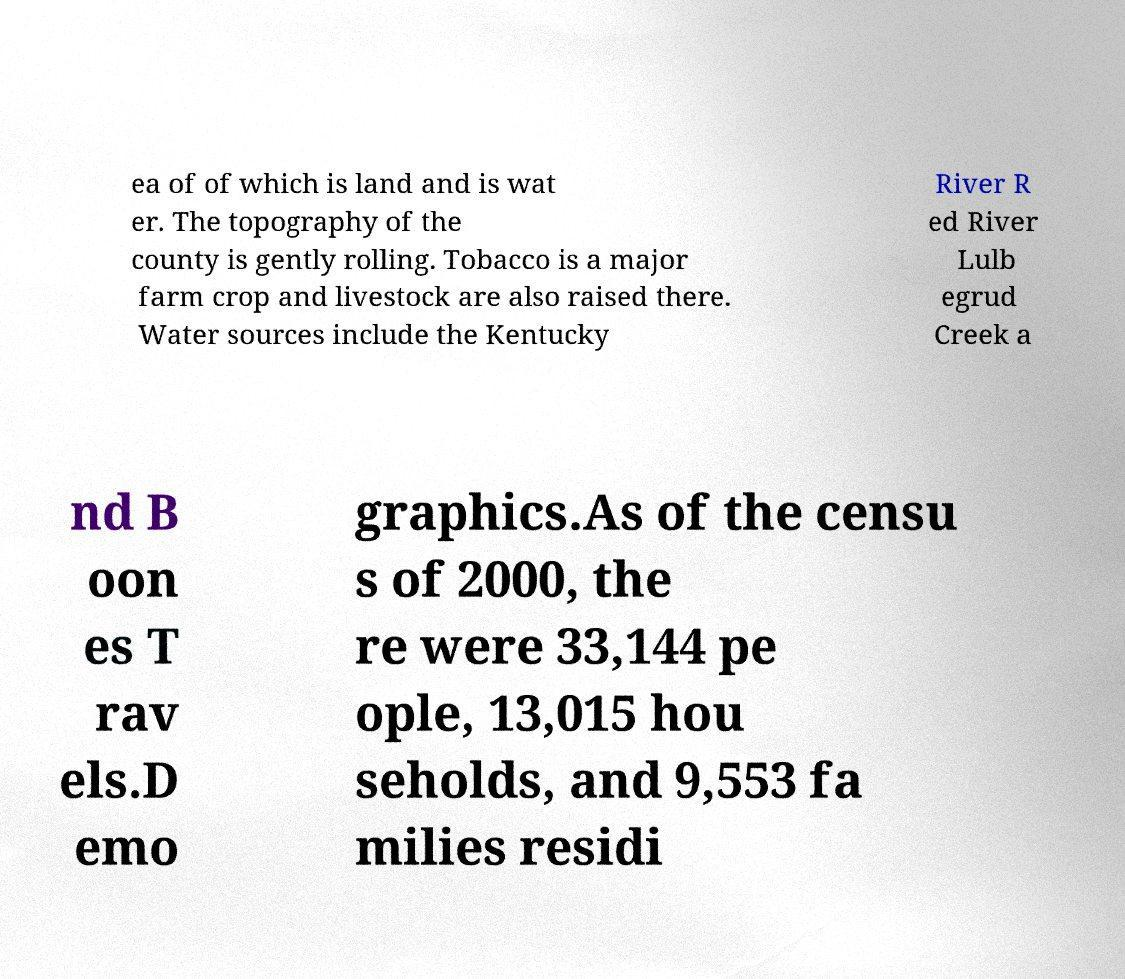For documentation purposes, I need the text within this image transcribed. Could you provide that? ea of of which is land and is wat er. The topography of the county is gently rolling. Tobacco is a major farm crop and livestock are also raised there. Water sources include the Kentucky River R ed River Lulb egrud Creek a nd B oon es T rav els.D emo graphics.As of the censu s of 2000, the re were 33,144 pe ople, 13,015 hou seholds, and 9,553 fa milies residi 